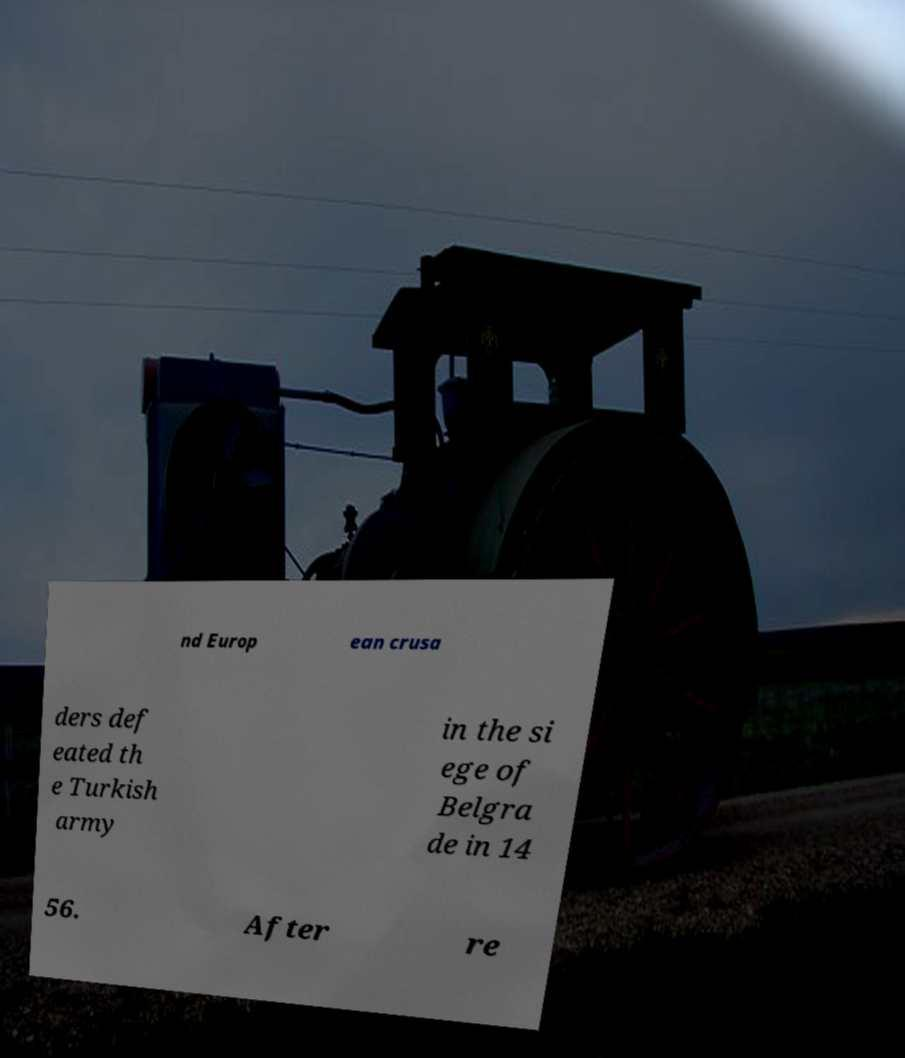Could you extract and type out the text from this image? nd Europ ean crusa ders def eated th e Turkish army in the si ege of Belgra de in 14 56. After re 